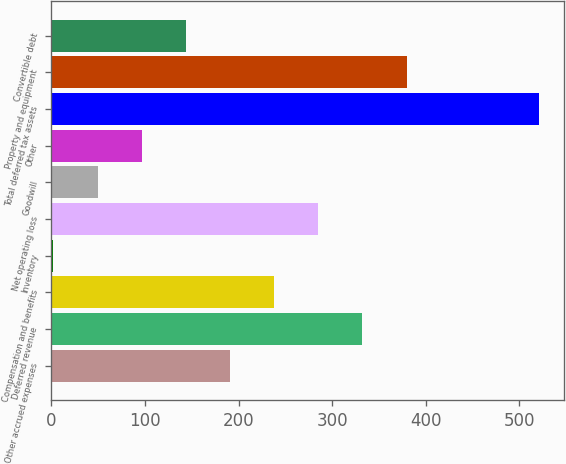<chart> <loc_0><loc_0><loc_500><loc_500><bar_chart><fcel>Other accrued expenses<fcel>Deferred revenue<fcel>Compensation and benefits<fcel>Inventory<fcel>Net operating loss<fcel>Goodwill<fcel>Other<fcel>Total deferred tax assets<fcel>Property and equipment<fcel>Convertible debt<nl><fcel>190.8<fcel>332.4<fcel>238<fcel>2<fcel>285.2<fcel>49.2<fcel>96.4<fcel>521.2<fcel>379.6<fcel>143.6<nl></chart> 